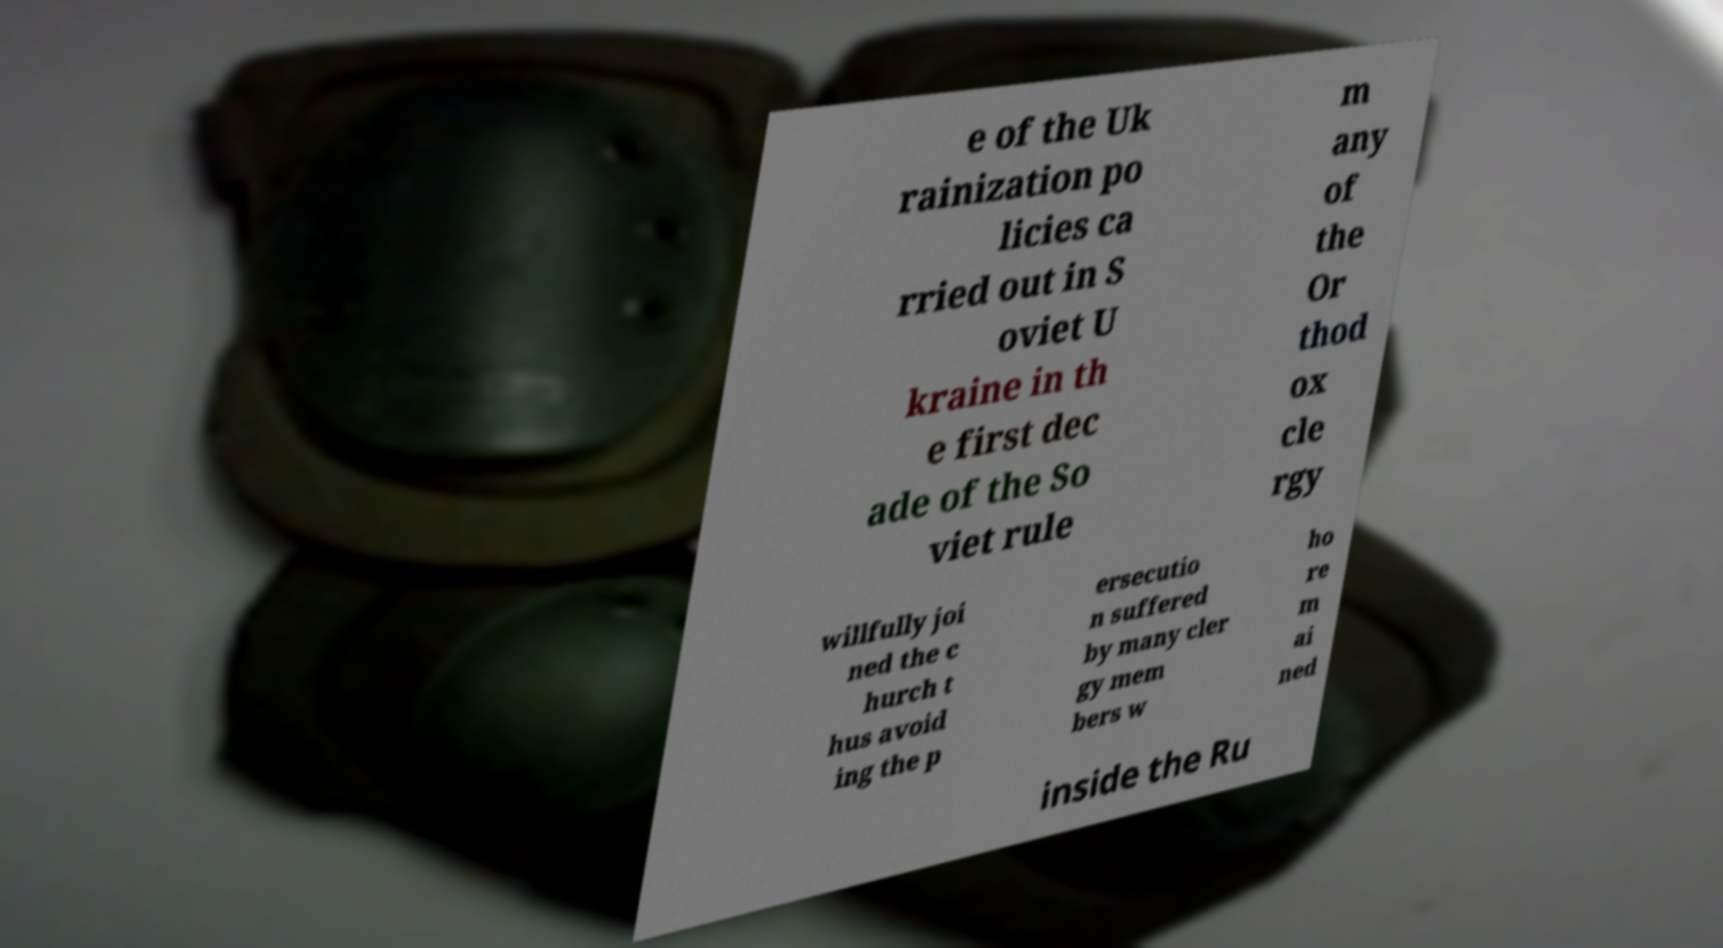Could you extract and type out the text from this image? e of the Uk rainization po licies ca rried out in S oviet U kraine in th e first dec ade of the So viet rule m any of the Or thod ox cle rgy willfully joi ned the c hurch t hus avoid ing the p ersecutio n suffered by many cler gy mem bers w ho re m ai ned inside the Ru 